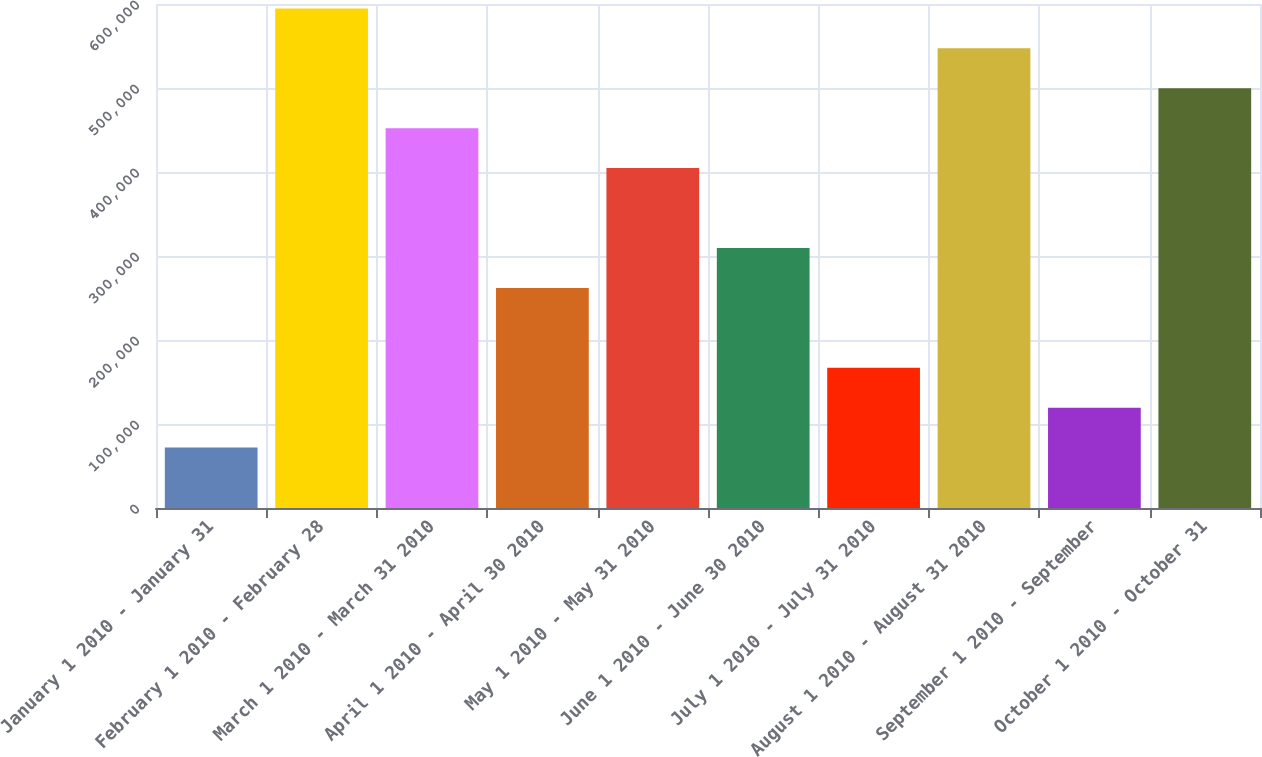<chart> <loc_0><loc_0><loc_500><loc_500><bar_chart><fcel>January 1 2010 - January 31<fcel>February 1 2010 - February 28<fcel>March 1 2010 - March 31 2010<fcel>April 1 2010 - April 30 2010<fcel>May 1 2010 - May 31 2010<fcel>June 1 2010 - June 30 2010<fcel>July 1 2010 - July 31 2010<fcel>August 1 2010 - August 31 2010<fcel>September 1 2010 - September<fcel>October 1 2010 - October 31<nl><fcel>71900<fcel>594752<fcel>452156<fcel>262028<fcel>404624<fcel>309560<fcel>166964<fcel>547220<fcel>119432<fcel>499688<nl></chart> 